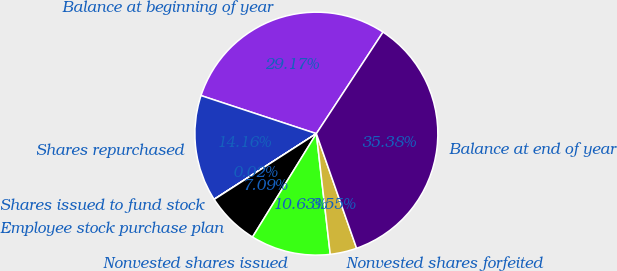Convert chart. <chart><loc_0><loc_0><loc_500><loc_500><pie_chart><fcel>Balance at beginning of year<fcel>Shares repurchased<fcel>Shares issued to fund stock<fcel>Employee stock purchase plan<fcel>Nonvested shares issued<fcel>Nonvested shares forfeited<fcel>Balance at end of year<nl><fcel>29.17%<fcel>14.16%<fcel>0.02%<fcel>7.09%<fcel>10.63%<fcel>3.55%<fcel>35.38%<nl></chart> 